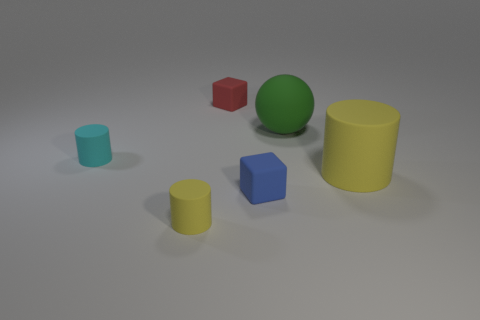How many rubber cylinders are both on the right side of the small yellow object and on the left side of the large yellow matte cylinder? 0 